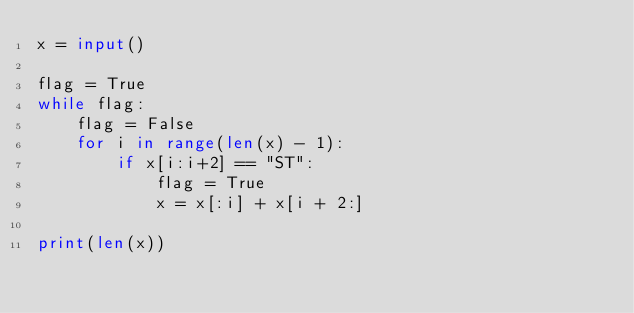Convert code to text. <code><loc_0><loc_0><loc_500><loc_500><_Python_>x = input()

flag = True
while flag:
    flag = False
    for i in range(len(x) - 1):
        if x[i:i+2] == "ST":
            flag = True
            x = x[:i] + x[i + 2:]

print(len(x))</code> 